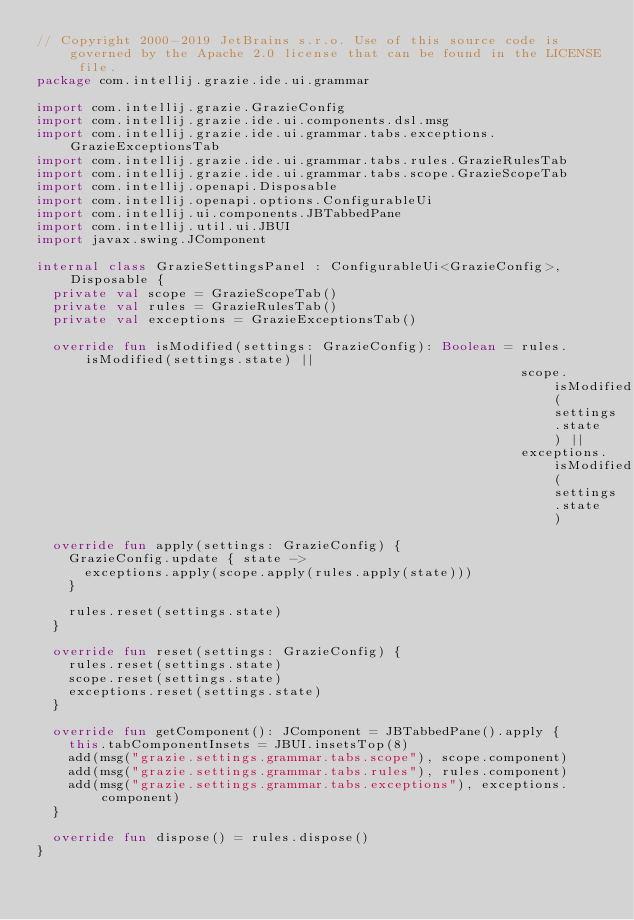Convert code to text. <code><loc_0><loc_0><loc_500><loc_500><_Kotlin_>// Copyright 2000-2019 JetBrains s.r.o. Use of this source code is governed by the Apache 2.0 license that can be found in the LICENSE file.
package com.intellij.grazie.ide.ui.grammar

import com.intellij.grazie.GrazieConfig
import com.intellij.grazie.ide.ui.components.dsl.msg
import com.intellij.grazie.ide.ui.grammar.tabs.exceptions.GrazieExceptionsTab
import com.intellij.grazie.ide.ui.grammar.tabs.rules.GrazieRulesTab
import com.intellij.grazie.ide.ui.grammar.tabs.scope.GrazieScopeTab
import com.intellij.openapi.Disposable
import com.intellij.openapi.options.ConfigurableUi
import com.intellij.ui.components.JBTabbedPane
import com.intellij.util.ui.JBUI
import javax.swing.JComponent

internal class GrazieSettingsPanel : ConfigurableUi<GrazieConfig>, Disposable {
  private val scope = GrazieScopeTab()
  private val rules = GrazieRulesTab()
  private val exceptions = GrazieExceptionsTab()

  override fun isModified(settings: GrazieConfig): Boolean = rules.isModified(settings.state) ||
                                                             scope.isModified(settings.state) ||
                                                             exceptions.isModified(settings.state)

  override fun apply(settings: GrazieConfig) {
    GrazieConfig.update { state ->
      exceptions.apply(scope.apply(rules.apply(state)))
    }

    rules.reset(settings.state)
  }

  override fun reset(settings: GrazieConfig) {
    rules.reset(settings.state)
    scope.reset(settings.state)
    exceptions.reset(settings.state)
  }

  override fun getComponent(): JComponent = JBTabbedPane().apply {
    this.tabComponentInsets = JBUI.insetsTop(8)
    add(msg("grazie.settings.grammar.tabs.scope"), scope.component)
    add(msg("grazie.settings.grammar.tabs.rules"), rules.component)
    add(msg("grazie.settings.grammar.tabs.exceptions"), exceptions.component)
  }

  override fun dispose() = rules.dispose()
}
</code> 